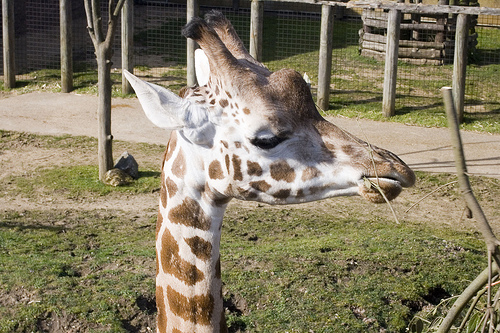<image>
Is there a fence behind the giraffe? Yes. From this viewpoint, the fence is positioned behind the giraffe, with the giraffe partially or fully occluding the fence. Where is the giraffe in relation to the grass? Is it in front of the grass? Yes. The giraffe is positioned in front of the grass, appearing closer to the camera viewpoint. 